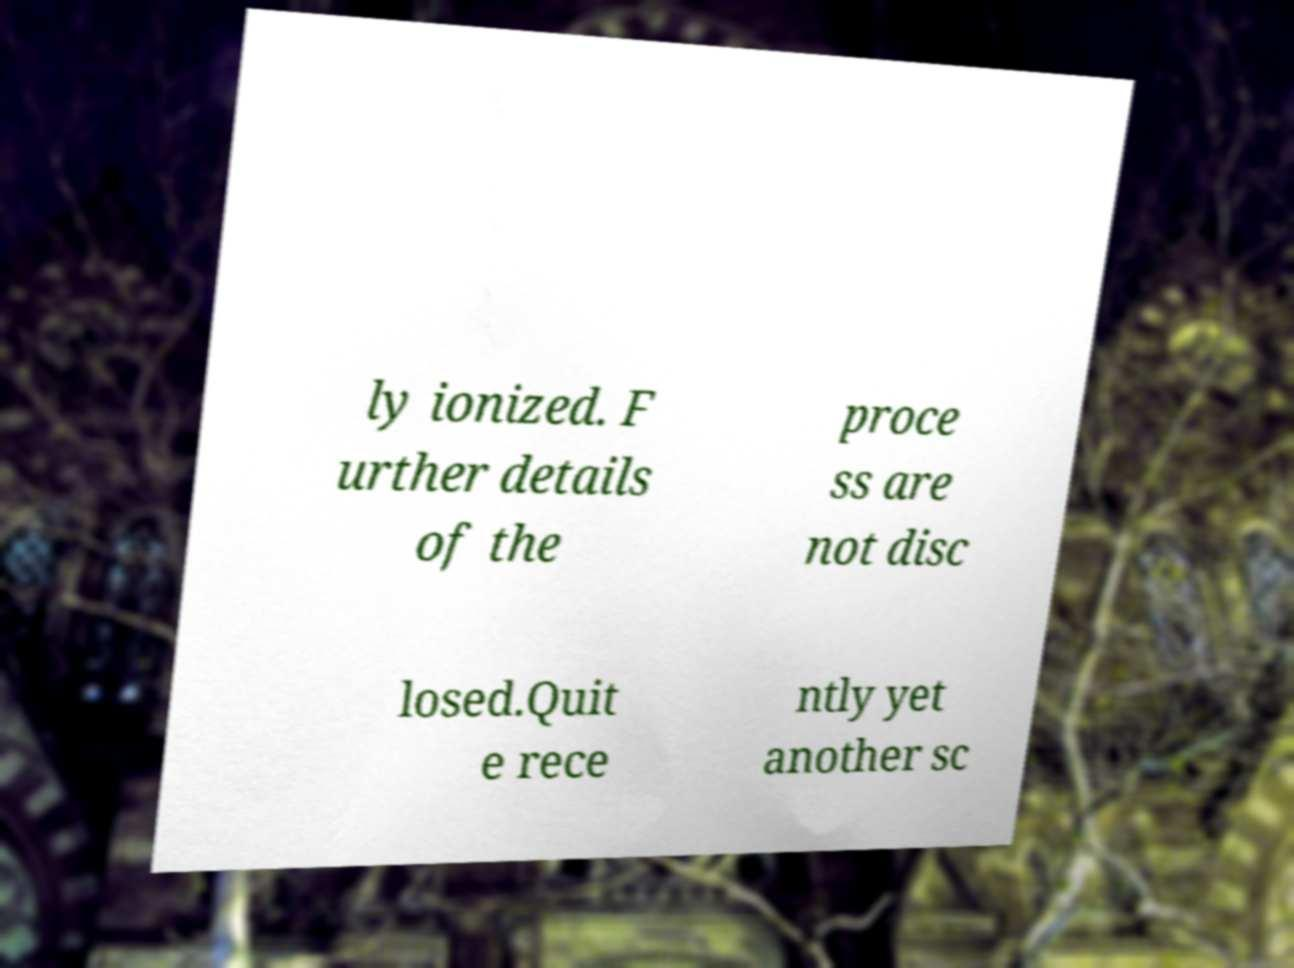Can you read and provide the text displayed in the image?This photo seems to have some interesting text. Can you extract and type it out for me? ly ionized. F urther details of the proce ss are not disc losed.Quit e rece ntly yet another sc 